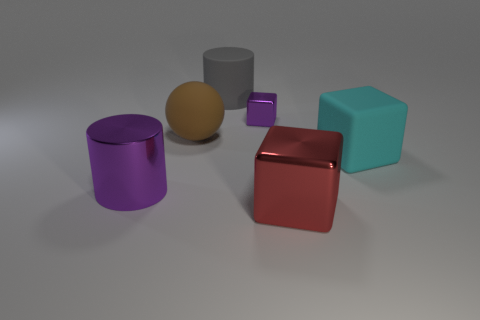What number of cubes are small gray objects or large objects?
Keep it short and to the point. 2. There is a cylinder that is in front of the large cyan object; is its color the same as the tiny metallic cube?
Provide a short and direct response. Yes. What is the cylinder that is behind the block behind the big thing that is right of the large red thing made of?
Offer a terse response. Rubber. Do the purple metallic cylinder and the red shiny block have the same size?
Your answer should be very brief. Yes. Do the metal cylinder and the shiny block that is behind the large purple cylinder have the same color?
Your answer should be very brief. Yes. There is a large gray thing that is made of the same material as the large brown object; what shape is it?
Ensure brevity in your answer.  Cylinder. Is the shape of the metallic object in front of the big purple object the same as  the small purple thing?
Your response must be concise. Yes. There is a metallic thing behind the cyan object that is behind the large purple metal cylinder; how big is it?
Keep it short and to the point. Small. What color is the cylinder that is the same material as the sphere?
Provide a short and direct response. Gray. What number of purple objects have the same size as the matte ball?
Make the answer very short. 1. 